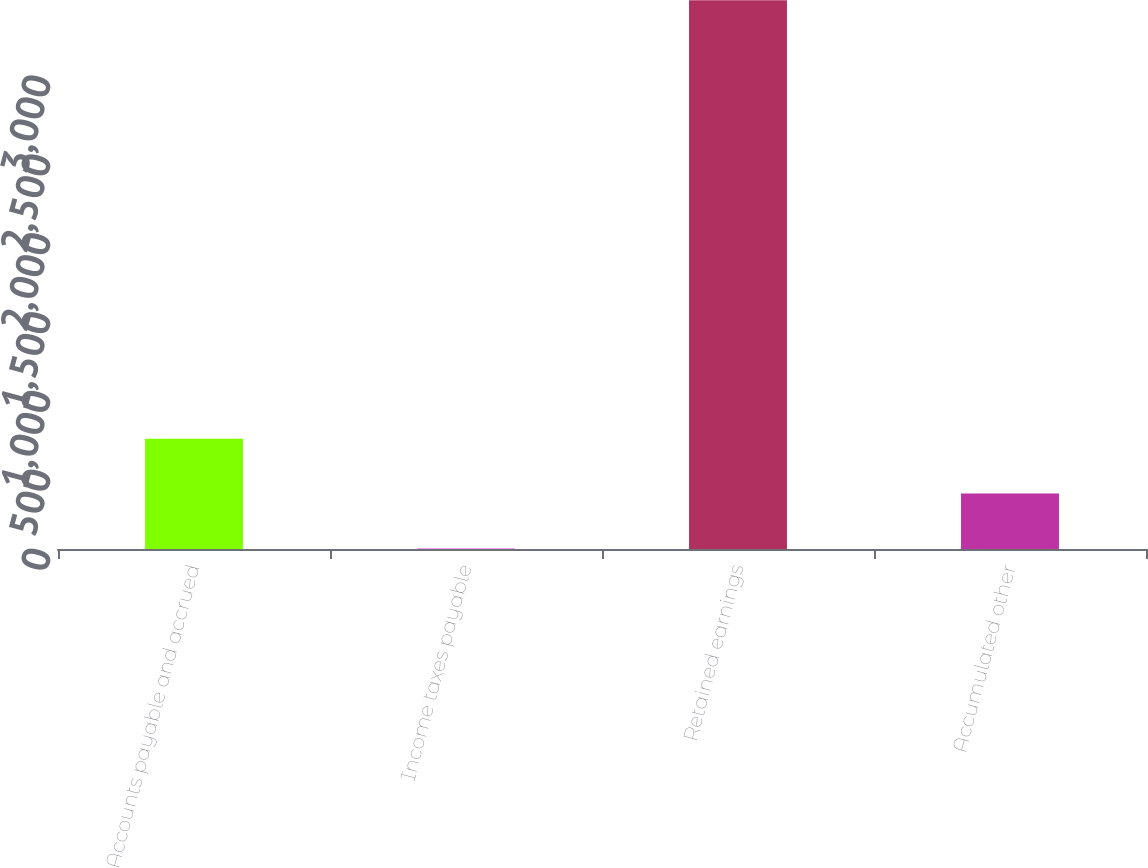Convert chart to OTSL. <chart><loc_0><loc_0><loc_500><loc_500><bar_chart><fcel>Accounts payable and accrued<fcel>Income taxes payable<fcel>Retained earnings<fcel>Accumulated other<nl><fcel>699.8<fcel>5<fcel>3479<fcel>352.4<nl></chart> 